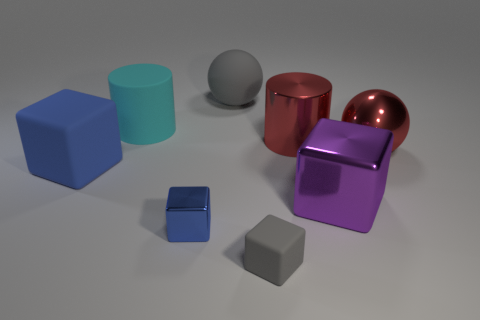Are there any green metallic balls? no 